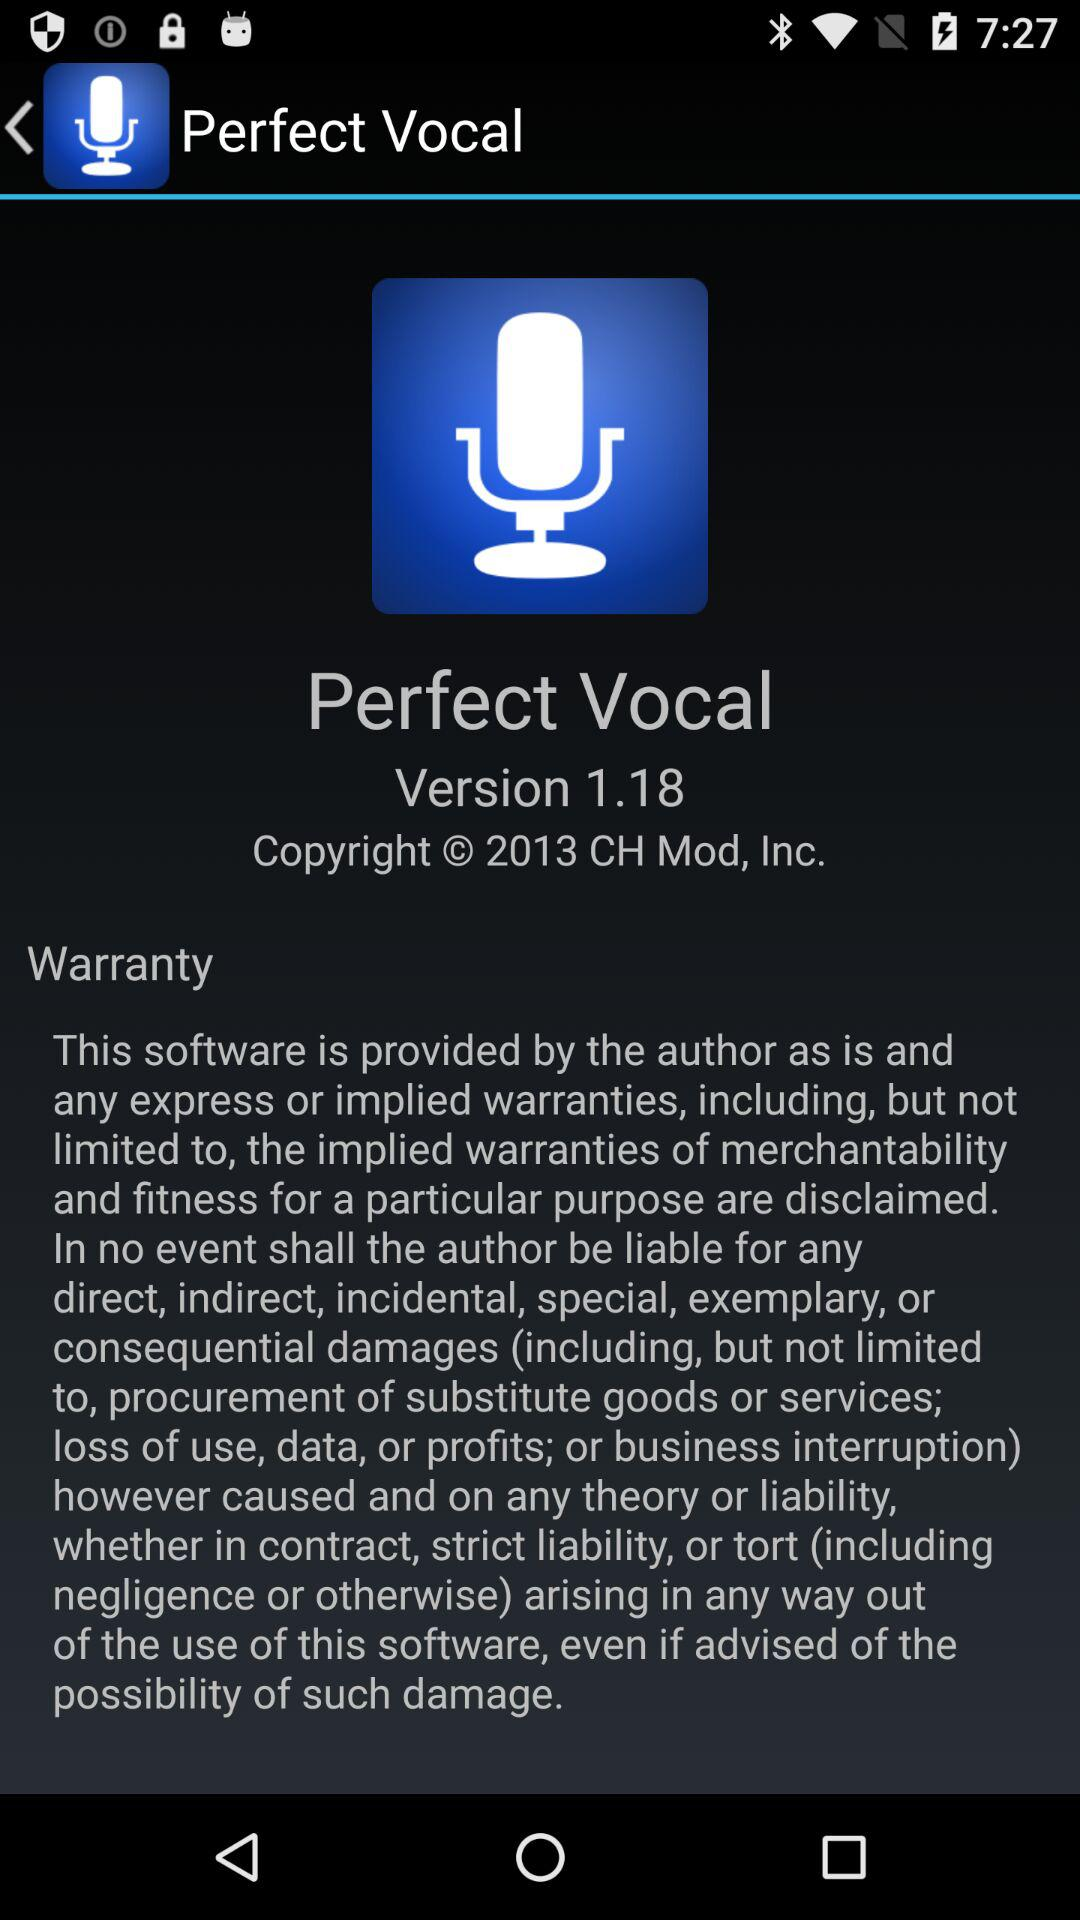What is the application name? The application name is "Perfect Vocal". 